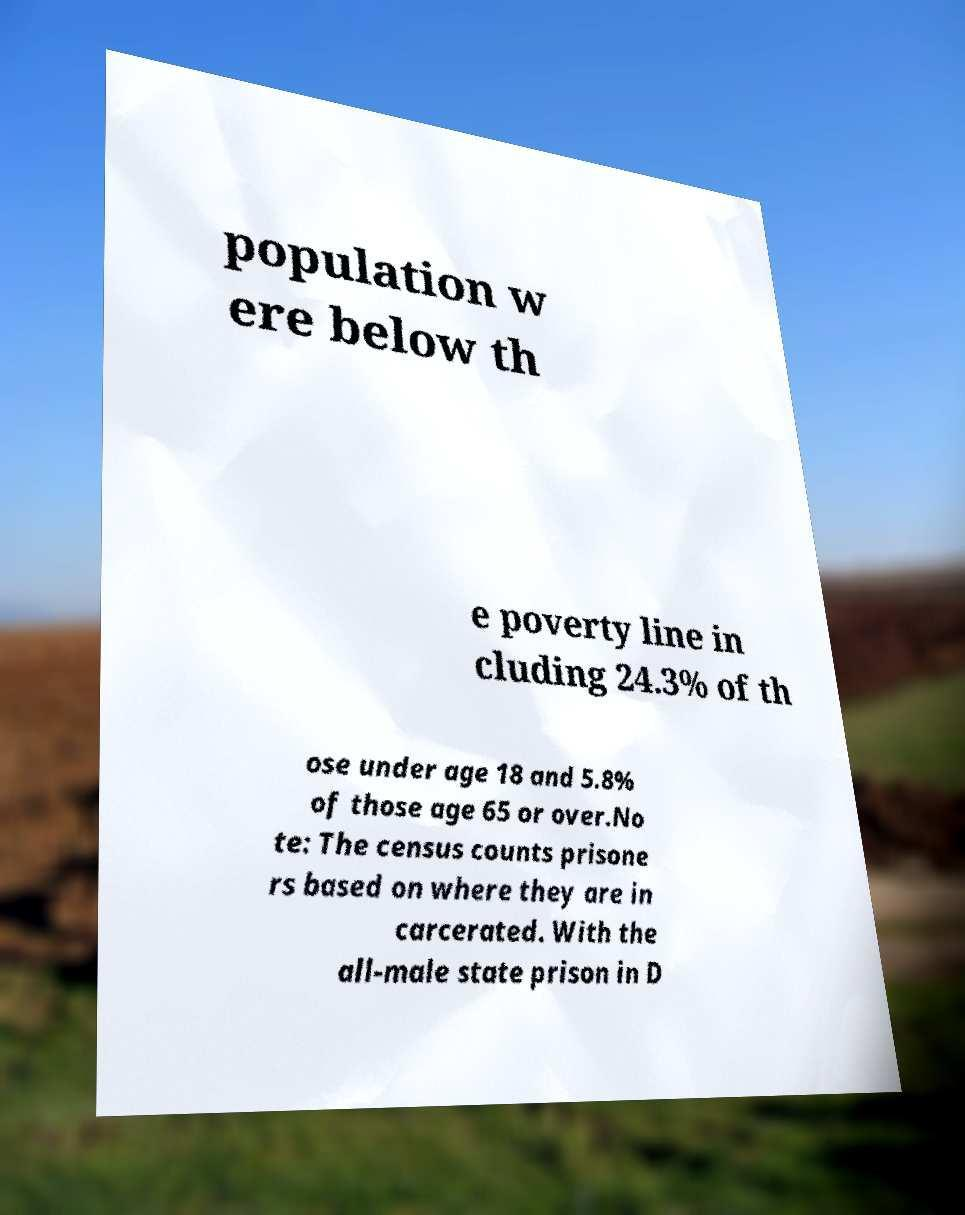Could you extract and type out the text from this image? population w ere below th e poverty line in cluding 24.3% of th ose under age 18 and 5.8% of those age 65 or over.No te: The census counts prisone rs based on where they are in carcerated. With the all-male state prison in D 